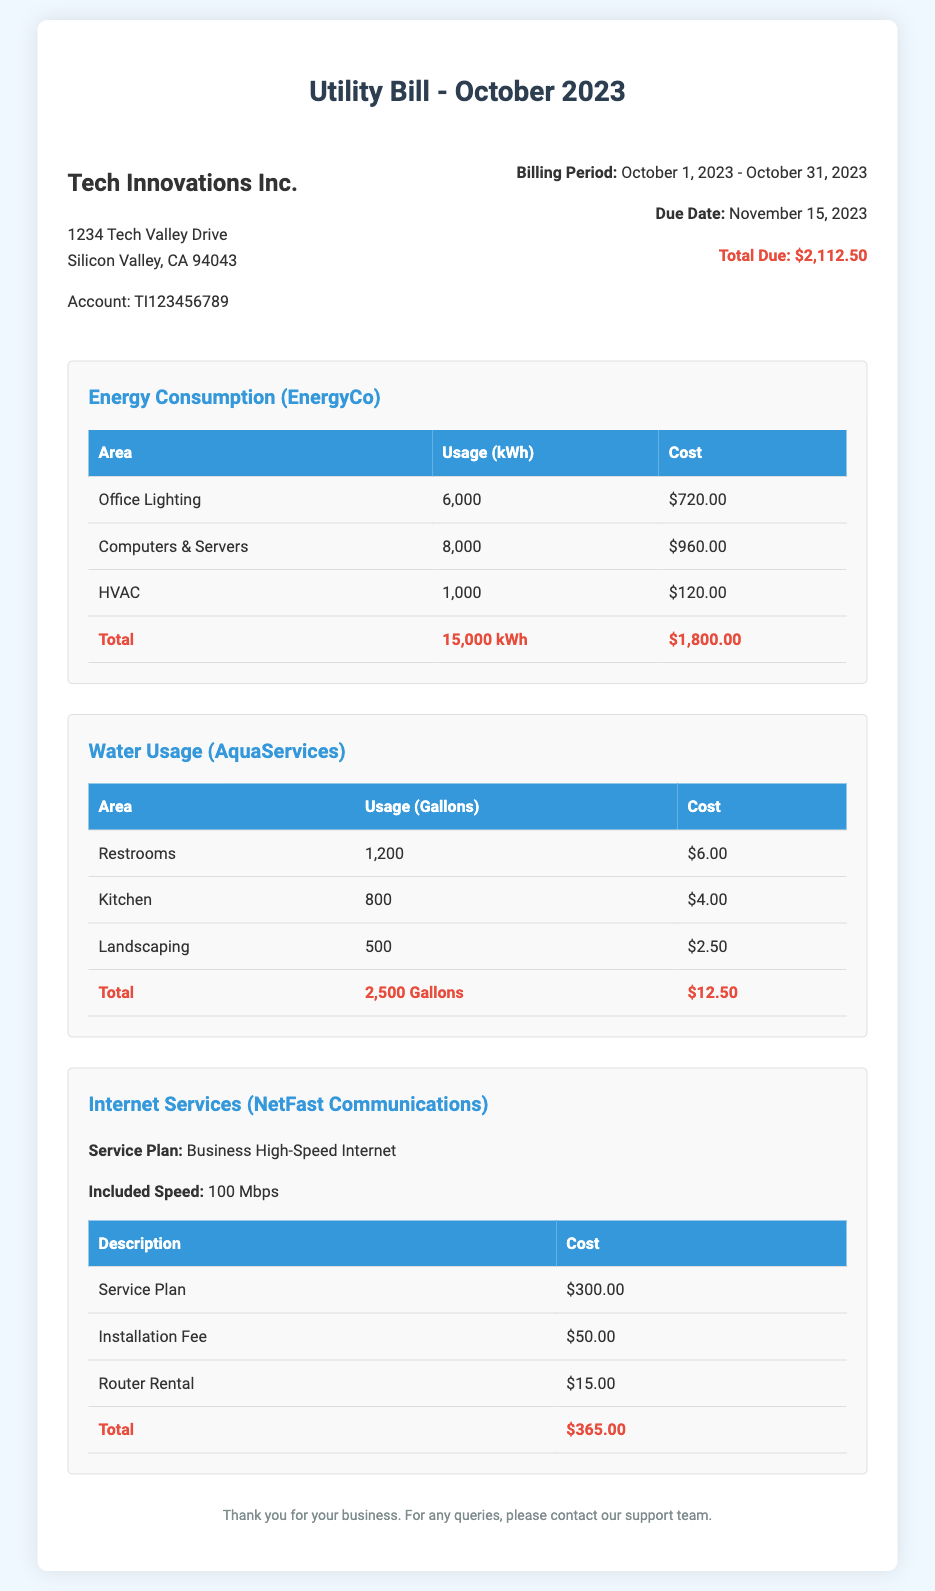What is the total due for the utility bill? The total due is listed prominently in the document as the culmination of all costs across services, which is shown as $2,112.50.
Answer: $2,112.50 How much was spent on office lighting? The cost for office lighting is presented in the energy consumption section as a distinct line item, specifically stated as $720.00.
Answer: $720.00 What is the total water usage in gallons? The total water usage is consolidated at the bottom of the water usage section, totaling 2,500 gallons as indicated in the final line of the table.
Answer: 2,500 Gallons What is the cost of the service plan for internet services? The document clearly specifies the cost of the service plan under the internet services section, which is explicitly listed as $300.00.
Answer: $300.00 How much is the HVAC energy usage? The energy consumption for HVAC is detailed in the energy consumption section as a separate line item, marked as $120.00.
Answer: $120.00 What is the due date for the utility bill? The due date is specified in the billing information section, clearly stated to be November 15, 2023.
Answer: November 15, 2023 What is the included speed of the internet service? The internet services section mentions the included speed clearly, which is stated as 100 Mbps.
Answer: 100 Mbps How much did the landscaping consume in water? The water usage for landscaping is explicitly noted in the document as a specific line item costing $2.50.
Answer: $2.50 What is the total cost for computers and servers energy consumption? The document explicitly lists the cost for the computers and servers, which is shown as $960.00.
Answer: $960.00 